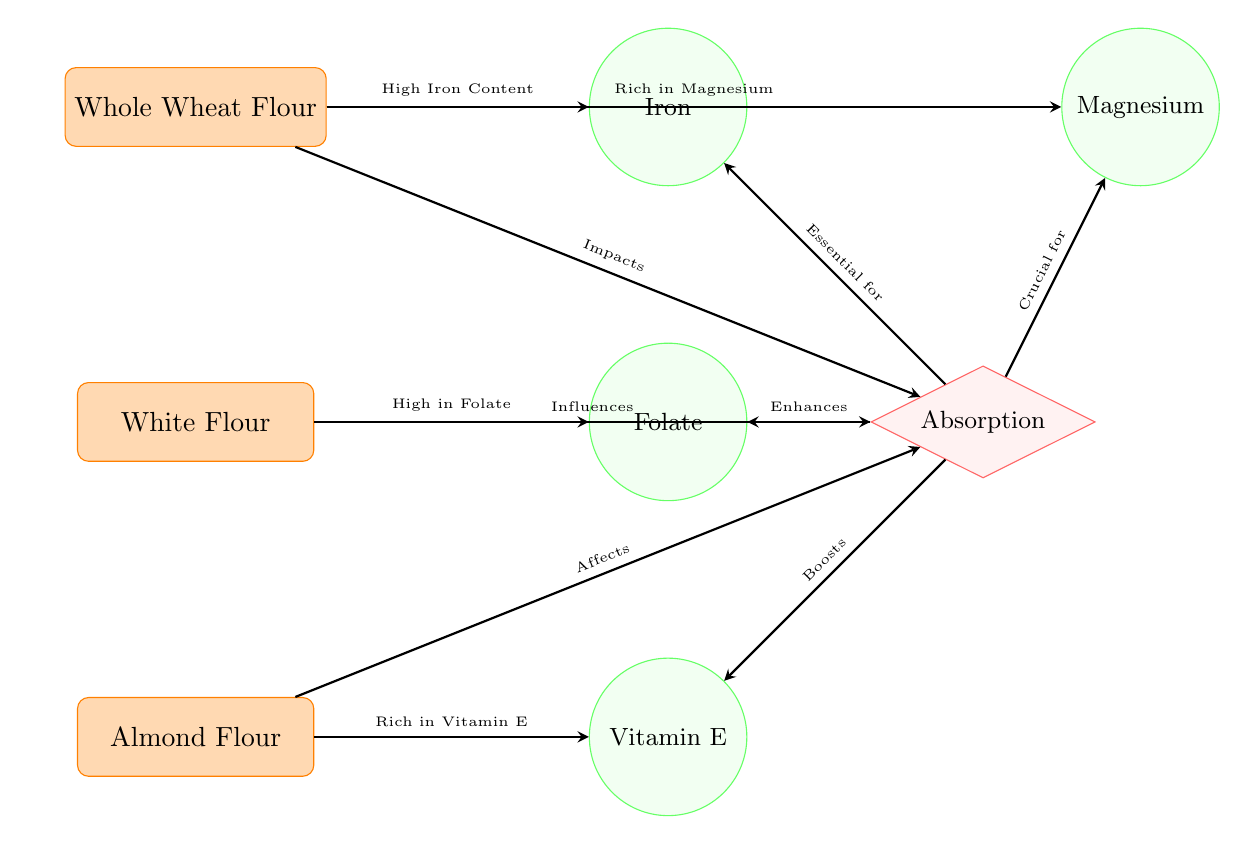What types of flour are represented in the diagram? The diagram contains three types of flour: Whole Wheat Flour, White Flour, and Almond Flour. These are represented as distinct nodes on the left side of the diagram.
Answer: Whole Wheat Flour, White Flour, Almond Flour Which nutrient is linked to Whole Wheat Flour? The arrow from Whole Wheat Flour points towards the Iron nutrient, indicating that Whole Wheat Flour has a high iron content. This relationship is shown directly in the diagram.
Answer: Iron How many nutrients are influenced by White Flour? White Flour is linked to one nutrient in the diagram, which is Folate. The diagram shows one direct arrow leading from White Flour to this nutrient.
Answer: 1 What is the effect of Whole Wheat Flour on absorption? The diagram shows an arrow leading from Whole Wheat Flour to the Absorption node, labeled "Impacts." This indicates that Whole Wheat Flour has a direct impact on nutrient absorption levels.
Answer: Impacts Which flour type is rich in Vitamin E? The Almond Flour is specifically noted in the diagram with an arrow indicating it is "Rich in Vitamin E," directly leading to the Vitamin E nutrient node.
Answer: Almond Flour What nutrient does Almond Flour affect regarding absorption? The diagram shows that Almond Flour affects nutrient absorption, denoted by the arrow pointing towards the Absorption node with the label "Affects." This tells us about the influence Almond Flour has on overall absorption levels.
Answer: Affects Why is Magnesium linked to absorption in the diagram? The diagram shows an arrow from Absorption to Magnesium labeled "Crucial for." This indicates that absorption levels are critically important for the uptake of Magnesium in the body, linking these two components.
Answer: Crucial for How many arrows point to the Absorption node? There are three arrows leading to the Absorption node in the diagram: one from Whole Wheat Flour, one from White Flour, and one from Almond Flour, indicating their collective influence on absorption levels.
Answer: 3 What is the relationship between Absorption and Folate? The diagram shows that absorption "Enhances" Folate, indicated by the arrow leading from the Absorption node to the Folate nutrient node. This suggests that higher nutrient absorption could improve Folate levels.
Answer: Enhances 